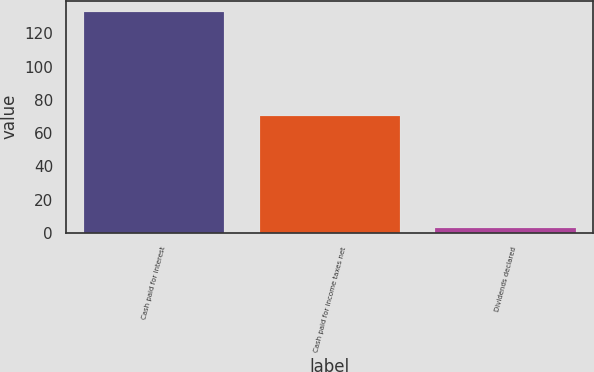<chart> <loc_0><loc_0><loc_500><loc_500><bar_chart><fcel>Cash paid for interest<fcel>Cash paid for income taxes net<fcel>Dividends declared<nl><fcel>133<fcel>70<fcel>3<nl></chart> 